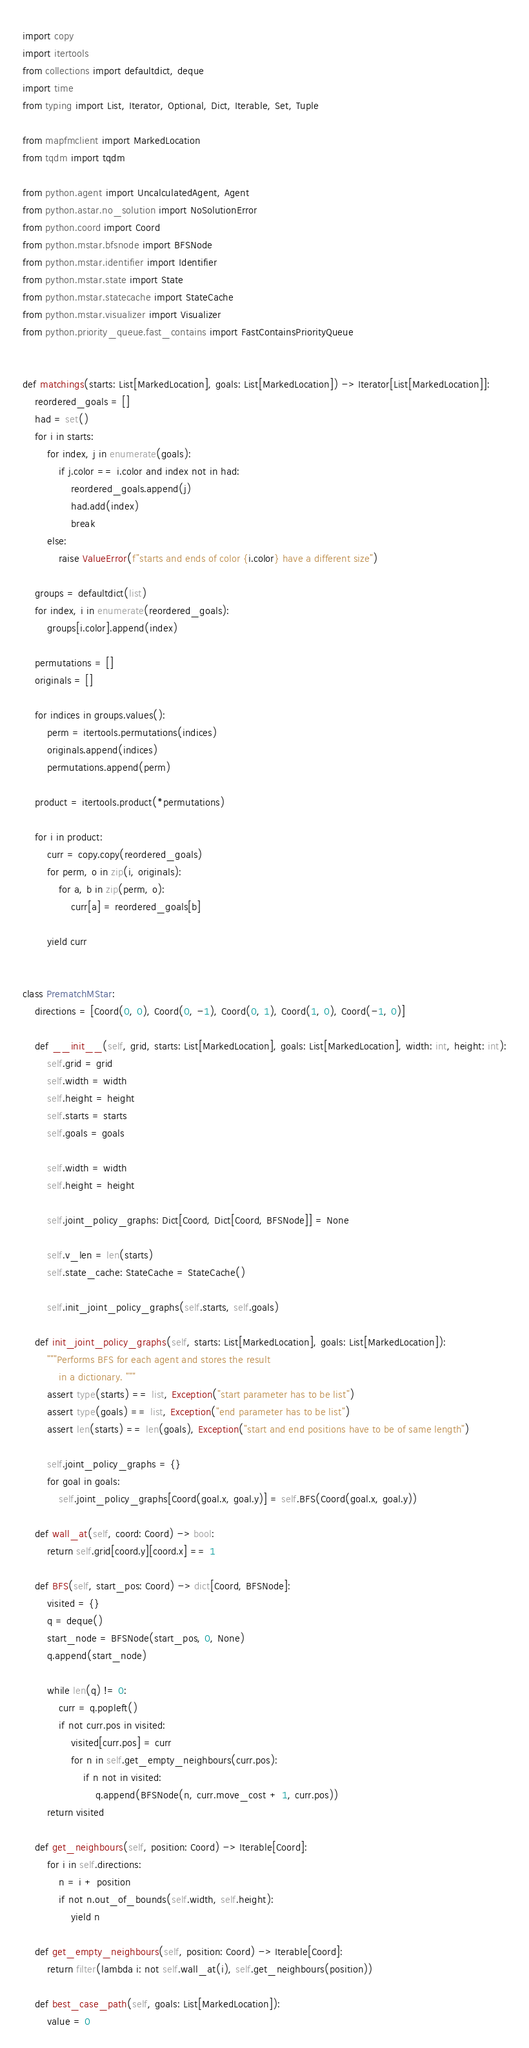<code> <loc_0><loc_0><loc_500><loc_500><_Python_>import copy
import itertools
from collections import defaultdict, deque
import time
from typing import List, Iterator, Optional, Dict, Iterable, Set, Tuple

from mapfmclient import MarkedLocation
from tqdm import tqdm

from python.agent import UncalculatedAgent, Agent
from python.astar.no_solution import NoSolutionError
from python.coord import Coord
from python.mstar.bfsnode import BFSNode
from python.mstar.identifier import Identifier
from python.mstar.state import State
from python.mstar.statecache import StateCache
from python.mstar.visualizer import Visualizer
from python.priority_queue.fast_contains import FastContainsPriorityQueue


def matchings(starts: List[MarkedLocation], goals: List[MarkedLocation]) -> Iterator[List[MarkedLocation]]:
    reordered_goals = []
    had = set()
    for i in starts:
        for index, j in enumerate(goals):
            if j.color == i.color and index not in had:
                reordered_goals.append(j)
                had.add(index)
                break
        else:
            raise ValueError(f"starts and ends of color {i.color} have a different size")

    groups = defaultdict(list)
    for index, i in enumerate(reordered_goals):
        groups[i.color].append(index)

    permutations = []
    originals = []

    for indices in groups.values():
        perm = itertools.permutations(indices)
        originals.append(indices)
        permutations.append(perm)

    product = itertools.product(*permutations)

    for i in product:
        curr = copy.copy(reordered_goals)
        for perm, o in zip(i, originals):
            for a, b in zip(perm, o):
                curr[a] = reordered_goals[b]

        yield curr


class PrematchMStar:
    directions = [Coord(0, 0), Coord(0, -1), Coord(0, 1), Coord(1, 0), Coord(-1, 0)]

    def __init__(self, grid, starts: List[MarkedLocation], goals: List[MarkedLocation], width: int, height: int):
        self.grid = grid
        self.width = width
        self.height = height
        self.starts = starts
        self.goals = goals

        self.width = width
        self.height = height

        self.joint_policy_graphs: Dict[Coord, Dict[Coord, BFSNode]] = None

        self.v_len = len(starts)
        self.state_cache: StateCache = StateCache()

        self.init_joint_policy_graphs(self.starts, self.goals)

    def init_joint_policy_graphs(self, starts: List[MarkedLocation], goals: List[MarkedLocation]):
        """Performs BFS for each agent and stores the result
            in a dictionary. """
        assert type(starts) == list, Exception("start parameter has to be list")
        assert type(goals) == list, Exception("end parameter has to be list")
        assert len(starts) == len(goals), Exception("start and end positions have to be of same length")

        self.joint_policy_graphs = {}
        for goal in goals:
            self.joint_policy_graphs[Coord(goal.x, goal.y)] = self.BFS(Coord(goal.x, goal.y))

    def wall_at(self, coord: Coord) -> bool:
        return self.grid[coord.y][coord.x] == 1

    def BFS(self, start_pos: Coord) -> dict[Coord, BFSNode]:
        visited = {}
        q = deque()
        start_node = BFSNode(start_pos, 0, None)
        q.append(start_node)

        while len(q) != 0:
            curr = q.popleft()
            if not curr.pos in visited:
                visited[curr.pos] = curr
                for n in self.get_empty_neighbours(curr.pos):
                    if n not in visited:
                        q.append(BFSNode(n, curr.move_cost + 1, curr.pos))
        return visited

    def get_neighbours(self, position: Coord) -> Iterable[Coord]:
        for i in self.directions:
            n = i + position
            if not n.out_of_bounds(self.width, self.height):
                yield n

    def get_empty_neighbours(self, position: Coord) -> Iterable[Coord]:
        return filter(lambda i: not self.wall_at(i), self.get_neighbours(position))

    def best_case_path(self, goals: List[MarkedLocation]):
        value = 0</code> 